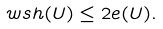Convert formula to latex. <formula><loc_0><loc_0><loc_500><loc_500>\label l { e q \colon d i s p l 2 } \ w s h ( U ) \leq 2 e ( U ) .</formula> 